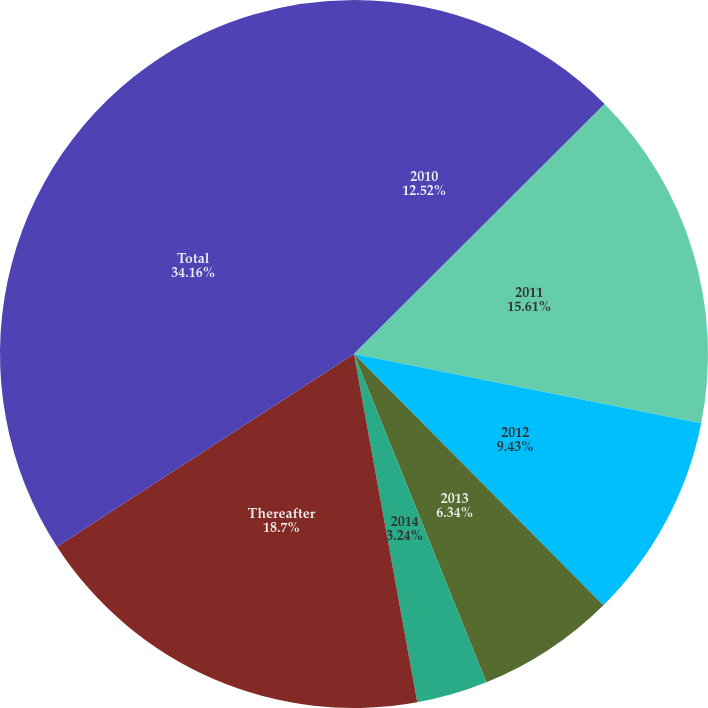<chart> <loc_0><loc_0><loc_500><loc_500><pie_chart><fcel>2010<fcel>2011<fcel>2012<fcel>2013<fcel>2014<fcel>Thereafter<fcel>Total<nl><fcel>12.52%<fcel>15.61%<fcel>9.43%<fcel>6.34%<fcel>3.24%<fcel>18.7%<fcel>34.16%<nl></chart> 